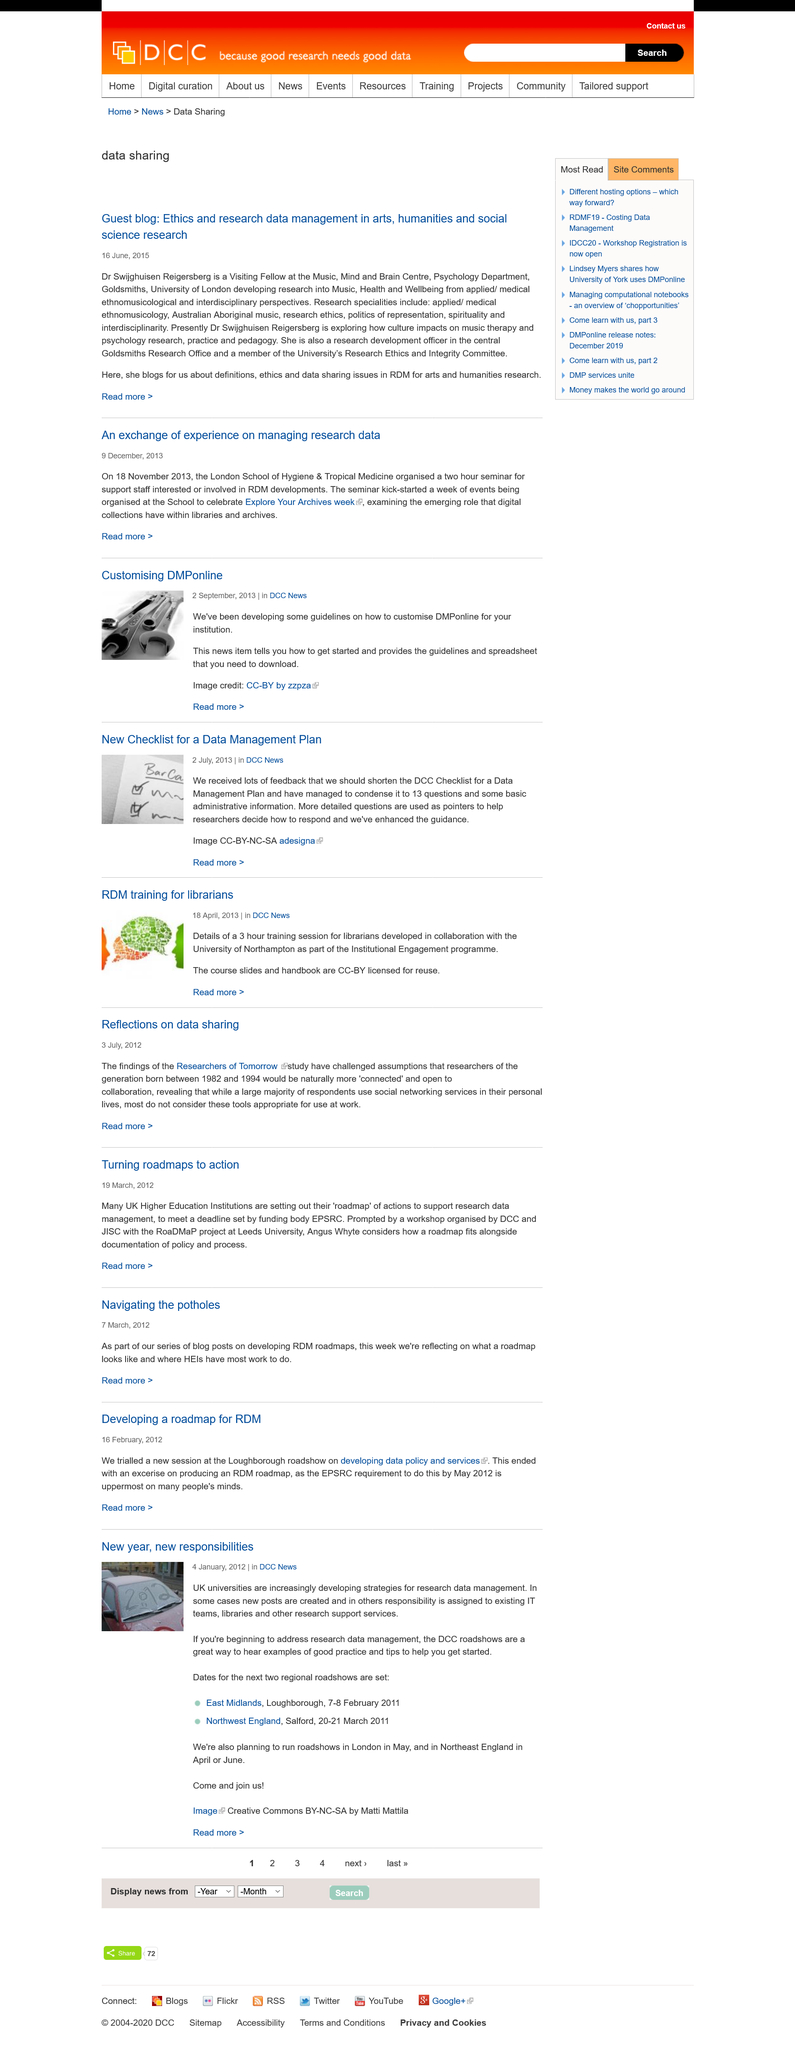Specify some key components in this picture. The title of the first blog is "Guest blog: Ethics and research data management in arts, humanities, and social science research... Dr. Swijghuisen Reigersberg is a Visiting Fellow at the Music, Mind, and Brain Centre, Psychology Department of Goldsmith, University of London. Dr. Reigersberg is conducting research into the fields of music, health, and wellbeing from an applied and medical ethnomusicological perspective, as well as from an interdisciplinary perspective. 